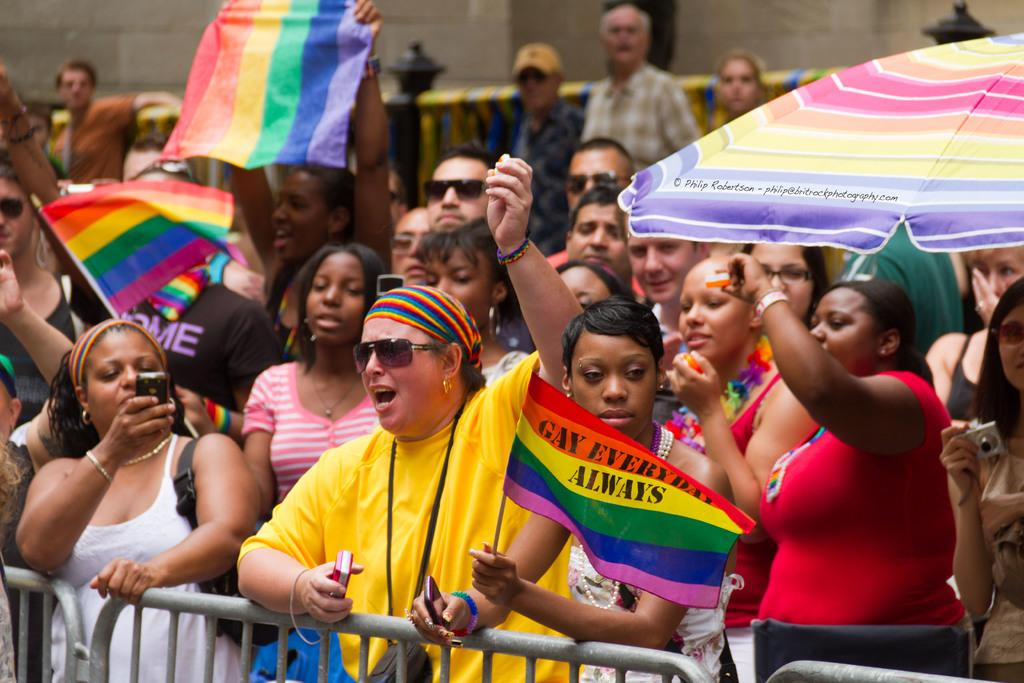Who is present in the image? There are women in the image. What are the women doing in the image? The women are standing in a protest. What items are the women holding in the image? The women are holding colorful flags and umbrellas. What can be seen in the front of the image? There is a railing grill in the front of the image. What type of destruction can be seen in the field behind the women? There is no field or destruction present in the image; it features women standing in a protest with colorful flags and umbrellas. 